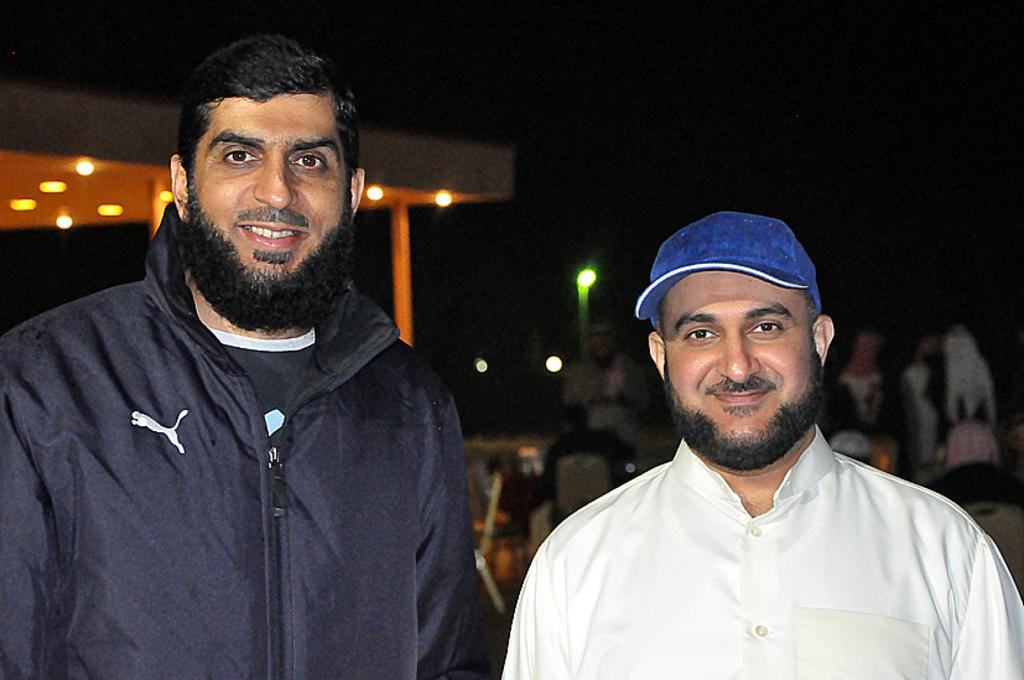How many people are in the foreground of the image? There are two men standing in the foreground of the image. What is one of the men wearing? One of the men is wearing a cap. What can be seen in the background of the image? There are buildings, lights, and some objects in the background of the image. What type of ice can be seen melting in harmony with the process in the image? There is no ice present in the image, nor is there any mention of a process or harmony. 